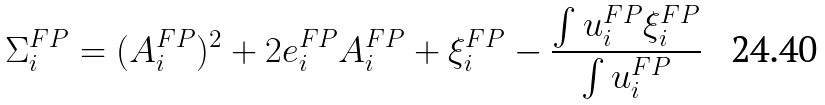Convert formula to latex. <formula><loc_0><loc_0><loc_500><loc_500>\Sigma _ { i } ^ { F P } = ( A _ { i } ^ { F P } ) ^ { 2 } + 2 e _ { i } ^ { F P } A _ { i } ^ { F P } + \xi _ { i } ^ { F P } - \frac { \int u _ { i } ^ { F P } \xi _ { i } ^ { F P } } { \int u _ { i } ^ { F P } }</formula> 